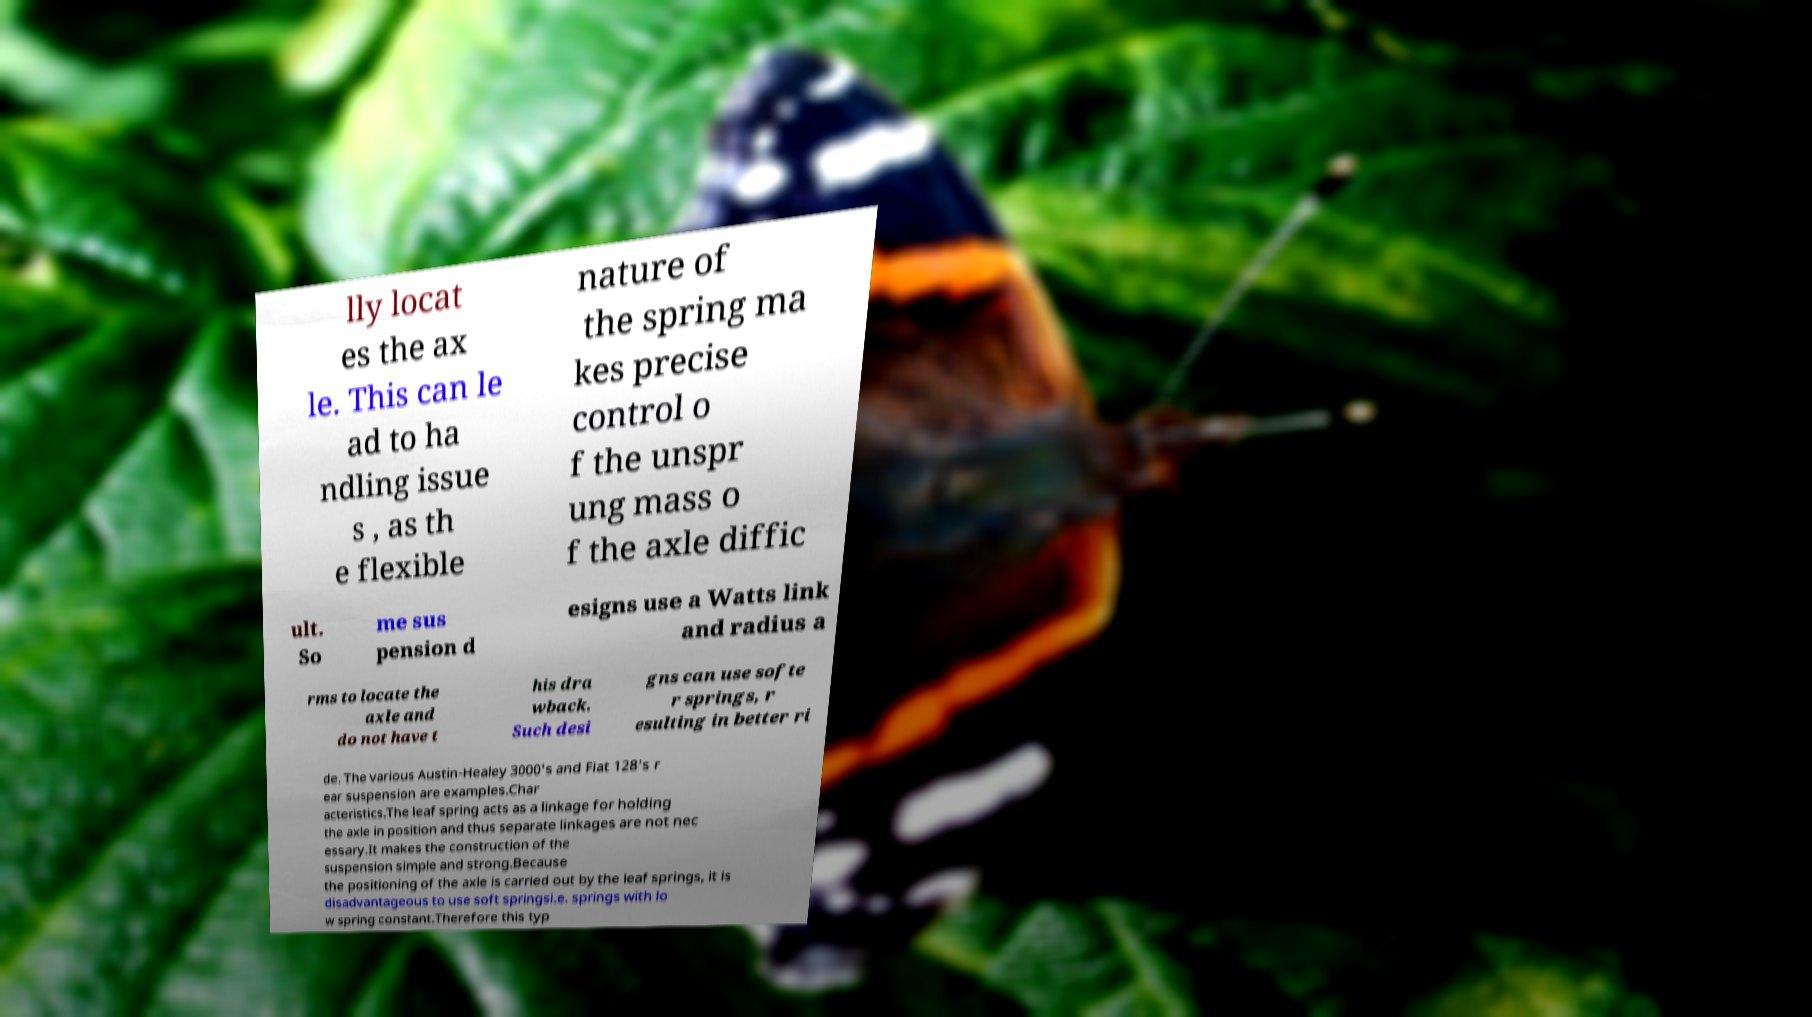Please identify and transcribe the text found in this image. lly locat es the ax le. This can le ad to ha ndling issue s , as th e flexible nature of the spring ma kes precise control o f the unspr ung mass o f the axle diffic ult. So me sus pension d esigns use a Watts link and radius a rms to locate the axle and do not have t his dra wback. Such desi gns can use softe r springs, r esulting in better ri de. The various Austin-Healey 3000's and Fiat 128's r ear suspension are examples.Char acteristics.The leaf spring acts as a linkage for holding the axle in position and thus separate linkages are not nec essary.It makes the construction of the suspension simple and strong.Because the positioning of the axle is carried out by the leaf springs, it is disadvantageous to use soft springsi.e. springs with lo w spring constant.Therefore this typ 